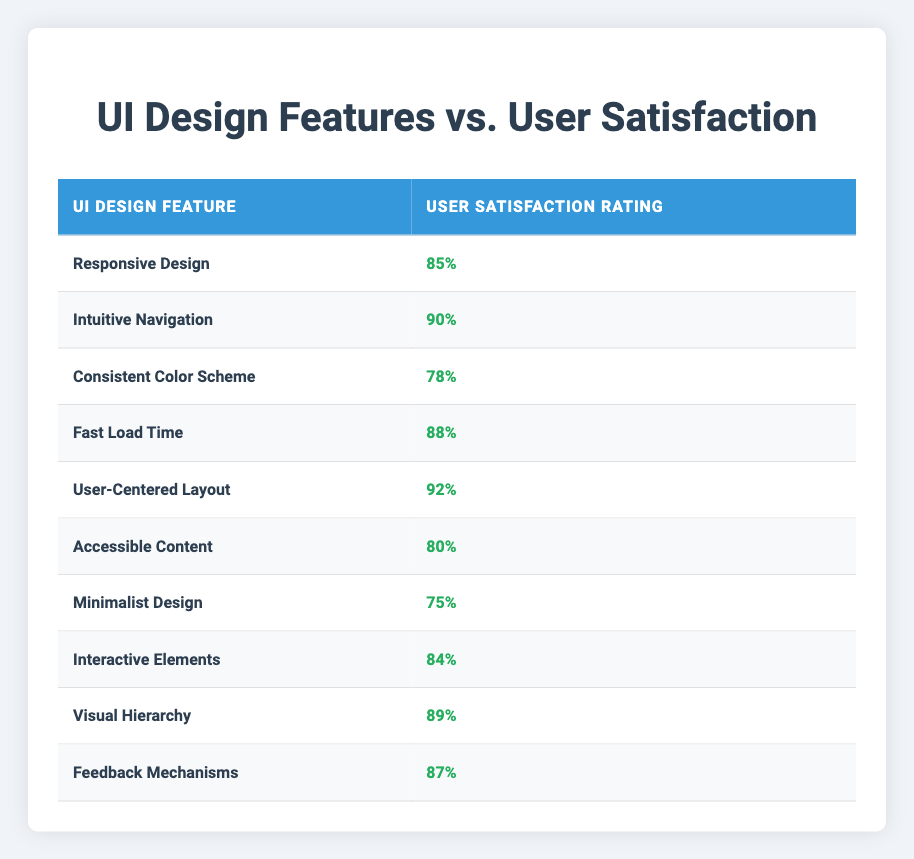What is the satisfaction rating for "Fast Load Time"? The table lists the rating associated with each design feature. For "Fast Load Time", the satisfaction rating is found directly in the corresponding row.
Answer: 88 Which design feature has the highest satisfaction rating? By examining the satisfaction ratings for all features, "User-Centered Layout" has the highest rating at 92, as indicated in the table.
Answer: User-Centered Layout What is the average satisfaction rating for all design features? To calculate the average, sum all the satisfaction ratings: 85 + 90 + 78 + 88 + 92 + 80 + 75 + 84 + 89 + 87 =  54, and then divide by the number of features (10). The sum is 885, and the average is 885/10 = 88.5.
Answer: 88.5 Is the satisfaction rating for "Consistent Color Scheme" greater than 80? The rating for "Consistent Color Scheme" is 78. Since 78 is less than 80, the statement is false.
Answer: No How many design features have a satisfaction rating greater than 85? To find this, we count the features with ratings above 85: "Responsive Design" (85), "Intuitive Navigation" (90), "Fast Load Time" (88), "User-Centered Layout" (92), "Visual Hierarchy" (89), and "Feedback Mechanisms" (87), totaling six features.
Answer: 6 Which feature has a satisfaction rating closest to the average of all ratings? The average rating, calculated as 88.5, is approached most closely by "Feedback Mechanisms" (87) and "Fast Load Time" (88) since they are the closest values to the average without exceeding it.
Answer: Feedback Mechanisms and Fast Load Time Has "Minimalist Design" received a satisfaction rating below 80? The satisfaction rating for "Minimalist Design" is 75 as shown in the table. This value is below 80, so the statement is true.
Answer: Yes What is the difference in satisfaction ratings between "User-Centered Layout" and "Minimalist Design"? To find the difference, subtract the rating for "Minimalist Design" (75) from "User-Centered Layout" (92): 92 - 75 = 17.
Answer: 17 Which feature shows the least satisfaction rating, and what is that rating? By reviewing the ratings in the table, "Minimalist Design" shows the least satisfaction at a rating of 75.
Answer: Minimalist Design, 75 